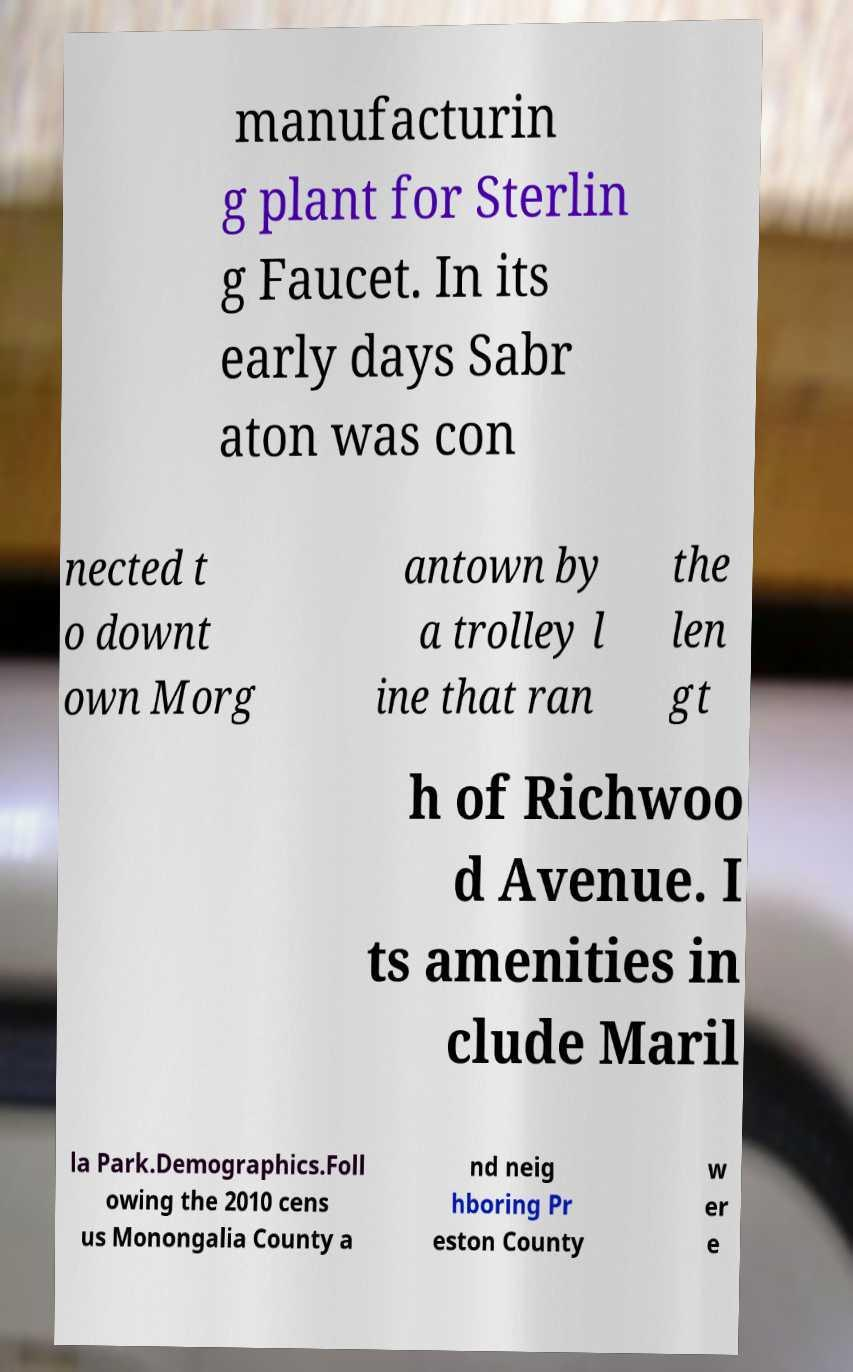For documentation purposes, I need the text within this image transcribed. Could you provide that? manufacturin g plant for Sterlin g Faucet. In its early days Sabr aton was con nected t o downt own Morg antown by a trolley l ine that ran the len gt h of Richwoo d Avenue. I ts amenities in clude Maril la Park.Demographics.Foll owing the 2010 cens us Monongalia County a nd neig hboring Pr eston County w er e 